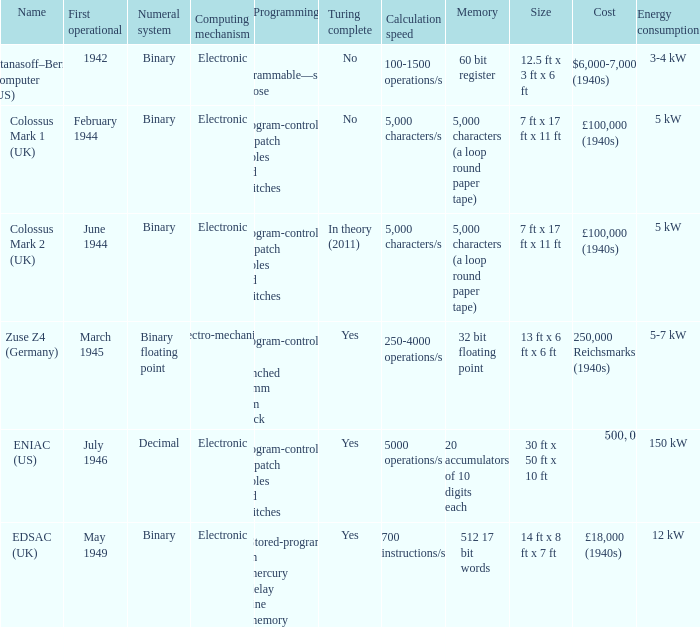What's the computing mechanbeingm with name being atanasoff–berry computer (us) Electronic. 